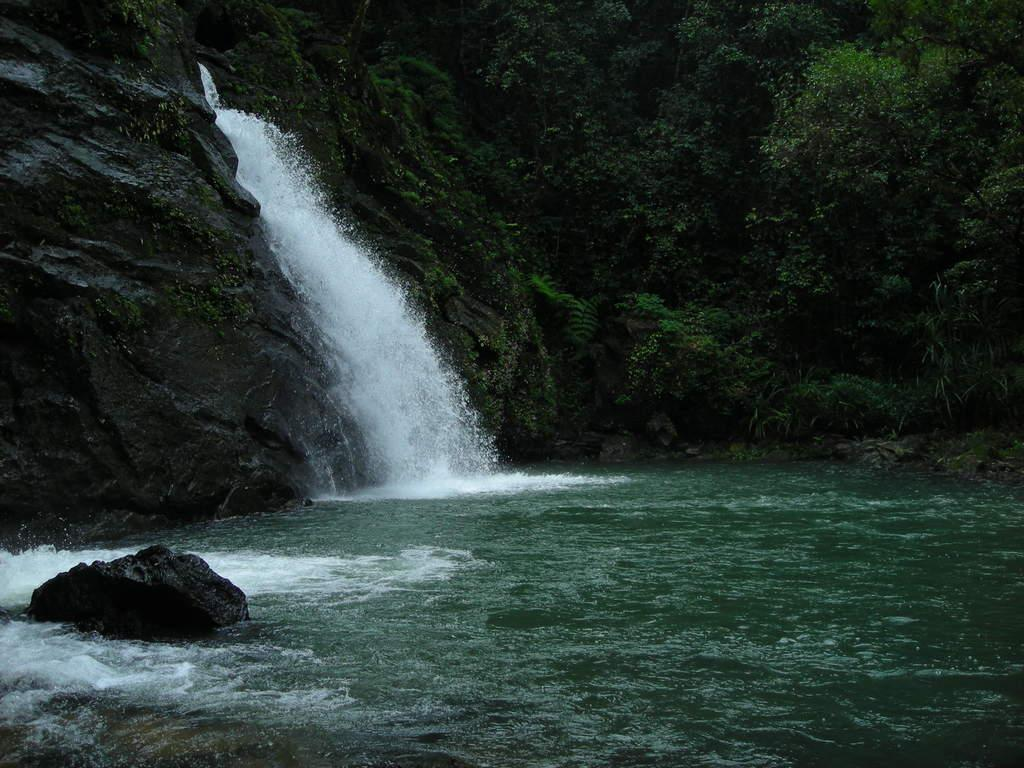What natural feature is the main subject of the image? There is a waterfall in the image. Where does the waterfall originate from? The waterfall is coming from a rock hill. What type of vegetation can be seen in the image? There are trees and plants in the image. What type of building can be seen near the waterfall in the image? There is no building present near the waterfall in the image. What type of club is located at the base of the waterfall in the image? There is no club present at the base of the waterfall in the image. 